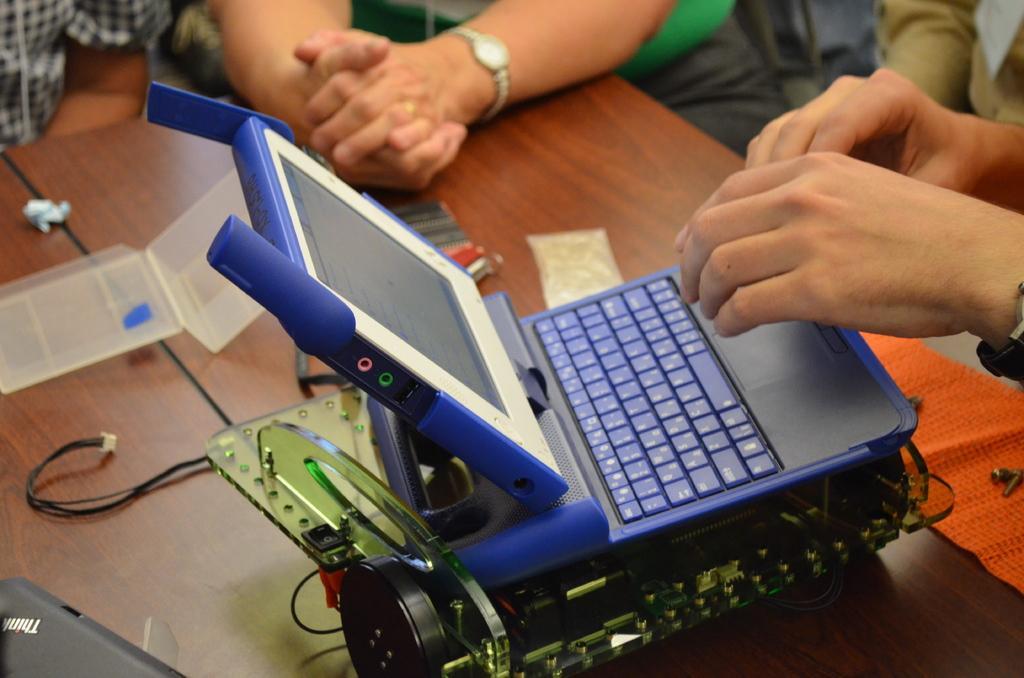Can you describe this image briefly? On the table I can see the small laptop, electronic object, cables, mat and other objects. Beside the table I can see many people who are sitting on the chair. 